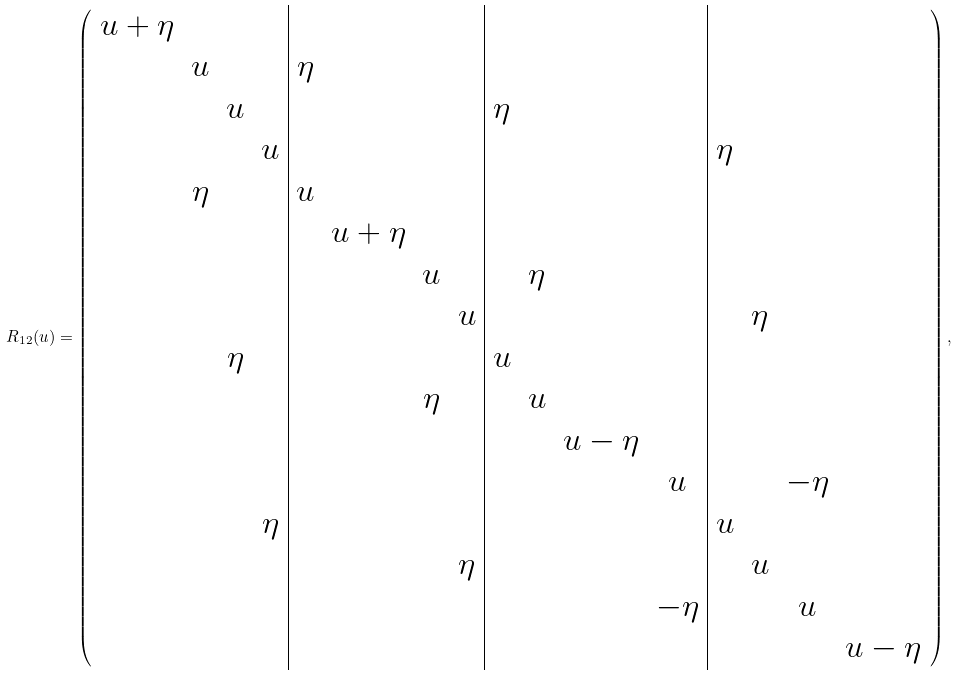Convert formula to latex. <formula><loc_0><loc_0><loc_500><loc_500>R _ { 1 2 } ( u ) = \left ( \begin{array} { c c c c | c c c c | c c c c | c c c c } u + \eta & & & & & & & & & & & & & & & \\ & u & & & \eta & & & & & & & & & & & \\ & & u & & & & & & \eta & & & & & & & \\ & & & u & & & & & & & & & \eta & & & \\ & \eta & & & u & & & & & & & & & & & \\ & & & & & u + \eta & & & & & & & & & & \\ & & & & & & u & & & \eta & & & & & & \\ & & & & & & & u & & & & & & \eta & & \\ & & \eta & & & & & & u & & & & & & & \\ & & & & & & \eta & & & u & & & & & & \\ & & & & & & & & & & u - \eta & & & & & \\ & & & & & & & & & & & u & & & - \eta & \\ & & & \eta & & & & & & & & & u & & & \\ & & & & & & & \eta & & & & & & u & & \\ & & & & & & & & & & & - \eta & & & u & \\ & & & & & & & & & & & & & & & u - \eta \\ \end{array} \right ) ,</formula> 